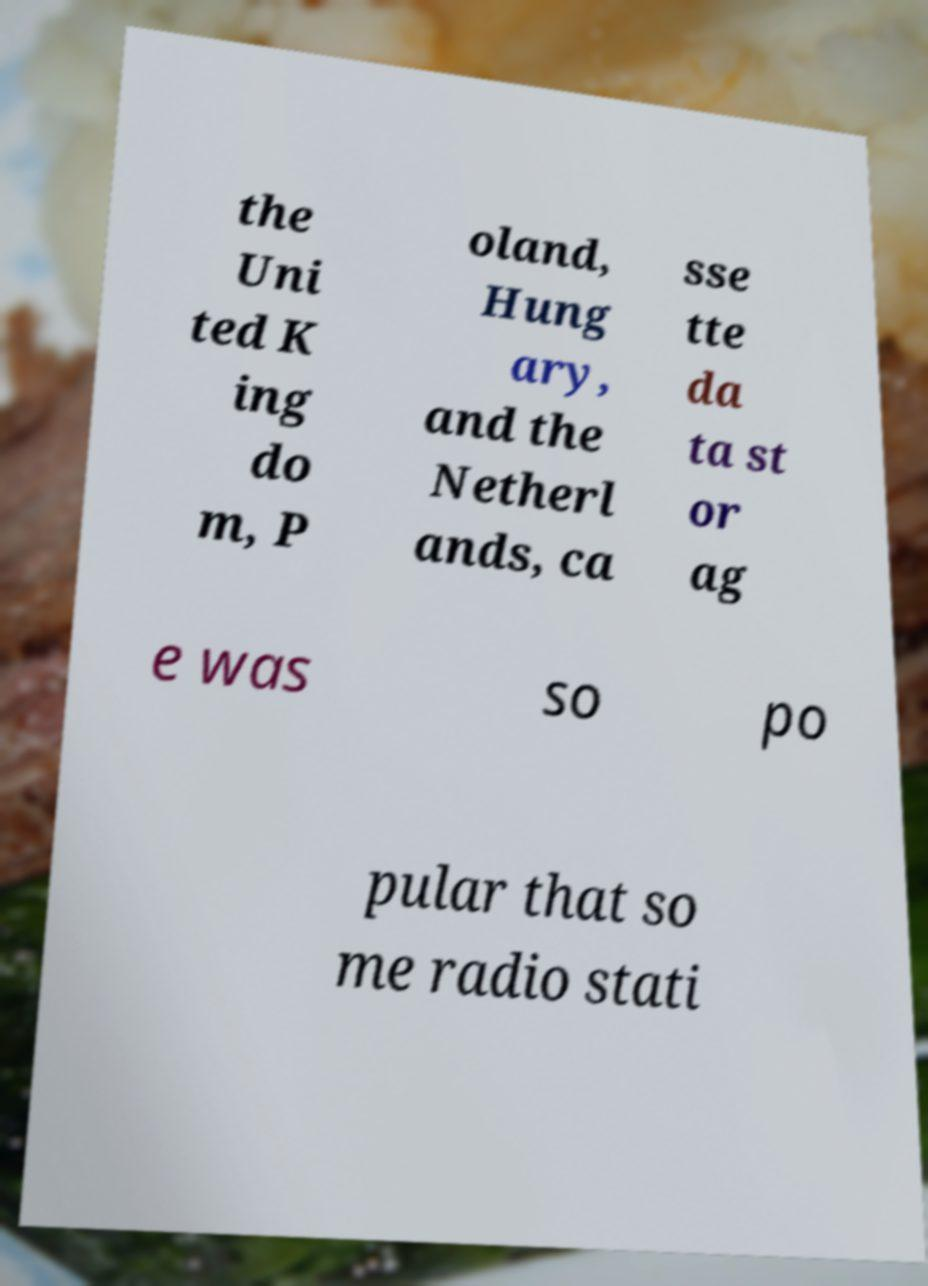For documentation purposes, I need the text within this image transcribed. Could you provide that? the Uni ted K ing do m, P oland, Hung ary, and the Netherl ands, ca sse tte da ta st or ag e was so po pular that so me radio stati 